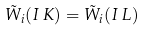<formula> <loc_0><loc_0><loc_500><loc_500>\tilde { W } _ { i } ( I \, K ) = \tilde { W } _ { i } ( I \, L )</formula> 